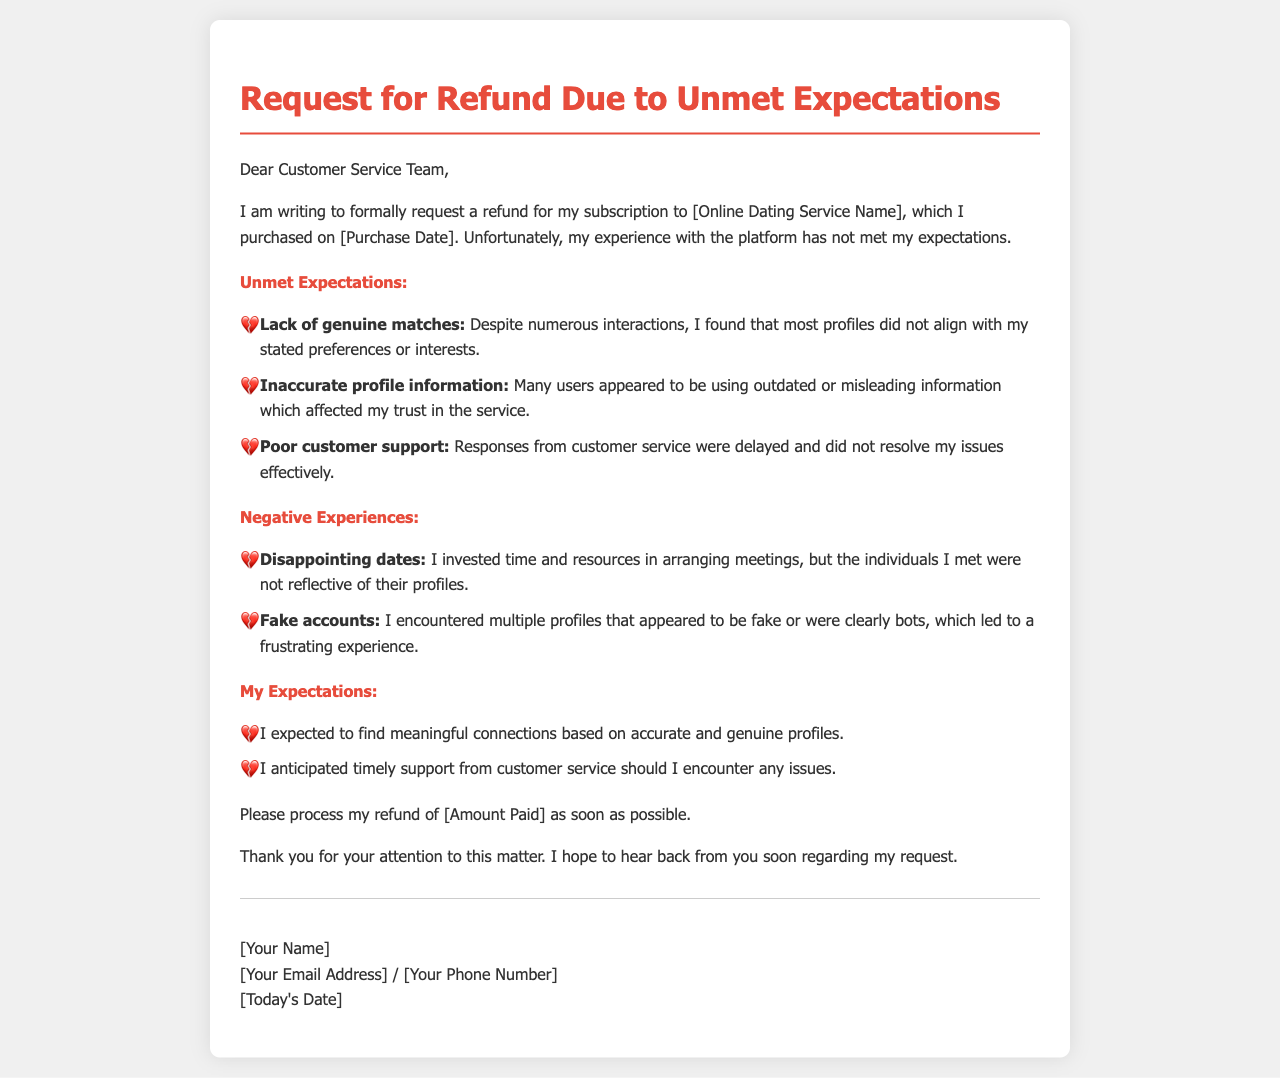What is the name of the online dating service? The document mentions the service as "[Online Dating Service Name]", indicating a placeholder for the actual name.
Answer: [Online Dating Service Name] What date was the subscription purchased? The document states the purchase date as "[Purchase Date]", suggesting a placeholder for the actual date.
Answer: [Purchase Date] What amount is being requested for refund? The letter requests a refund for "[Amount Paid]", indicating a placeholder for the actual amount paid.
Answer: [Amount Paid] What issue is highlighted under 'Unmet Expectations'? The letter points out "Lack of genuine matches" as one of the unmet expectations.
Answer: Lack of genuine matches What negative experience is mentioned regarding profiles? The document states that the author encountered "Fake accounts" as a significant negative experience.
Answer: Fake accounts What was expected from customer support? The author anticipated "timely support from customer service" if any issues arose.
Answer: timely support What type of connections did the author seek? The author expected to find "meaningful connections" based on accurate profiles.
Answer: meaningful connections What is the overall sentiment expressed in the letter? The tone of the document suggests a negative experience with the online dating service, as indicated by the multiple complaints outlined.
Answer: negative experience 